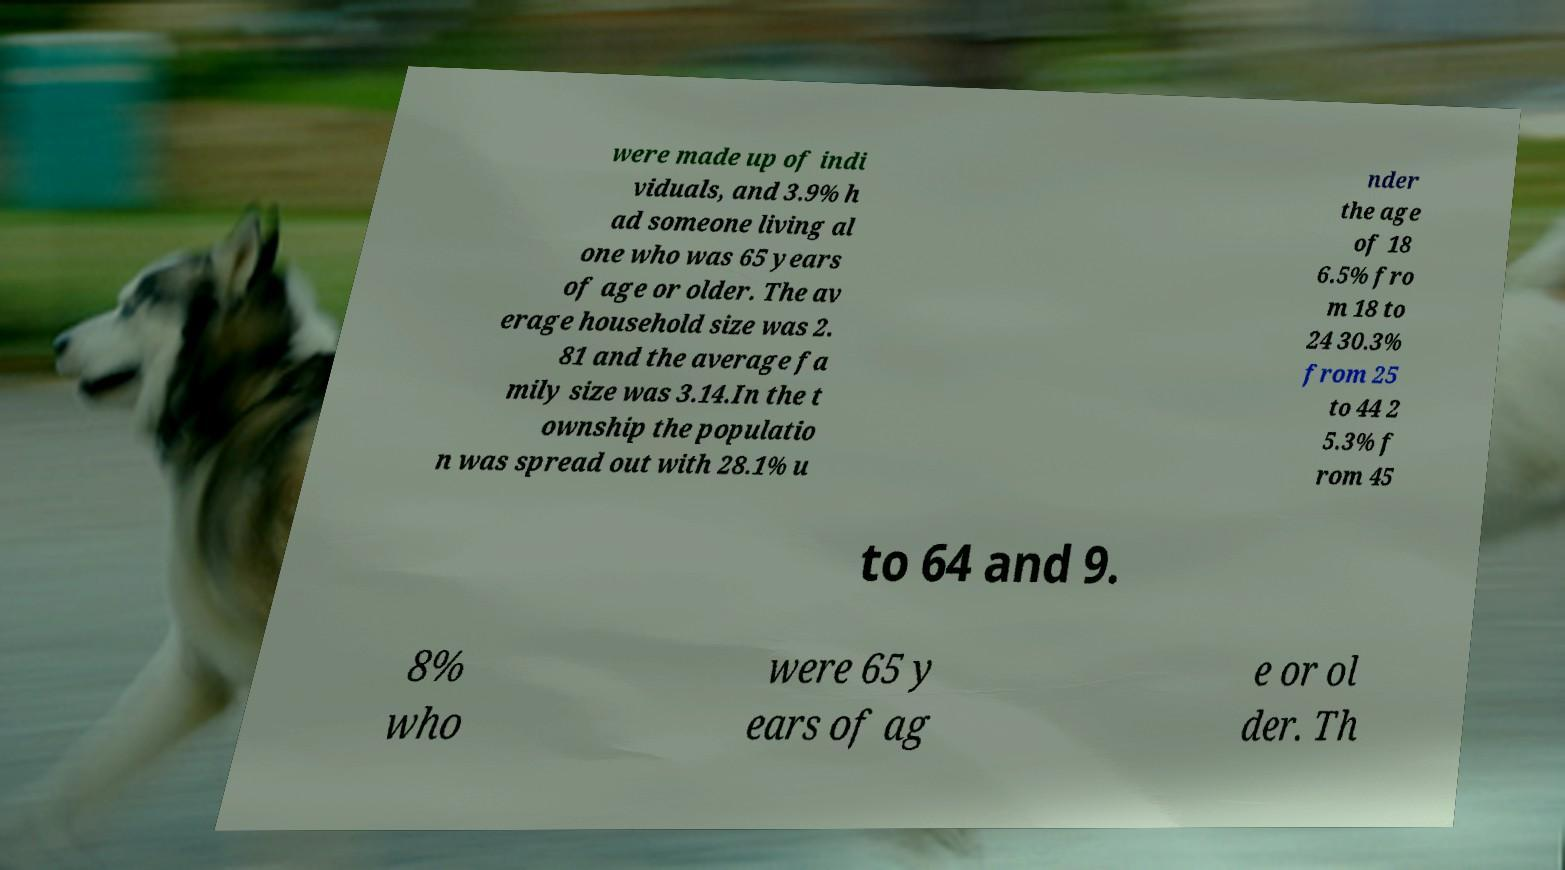Can you accurately transcribe the text from the provided image for me? were made up of indi viduals, and 3.9% h ad someone living al one who was 65 years of age or older. The av erage household size was 2. 81 and the average fa mily size was 3.14.In the t ownship the populatio n was spread out with 28.1% u nder the age of 18 6.5% fro m 18 to 24 30.3% from 25 to 44 2 5.3% f rom 45 to 64 and 9. 8% who were 65 y ears of ag e or ol der. Th 